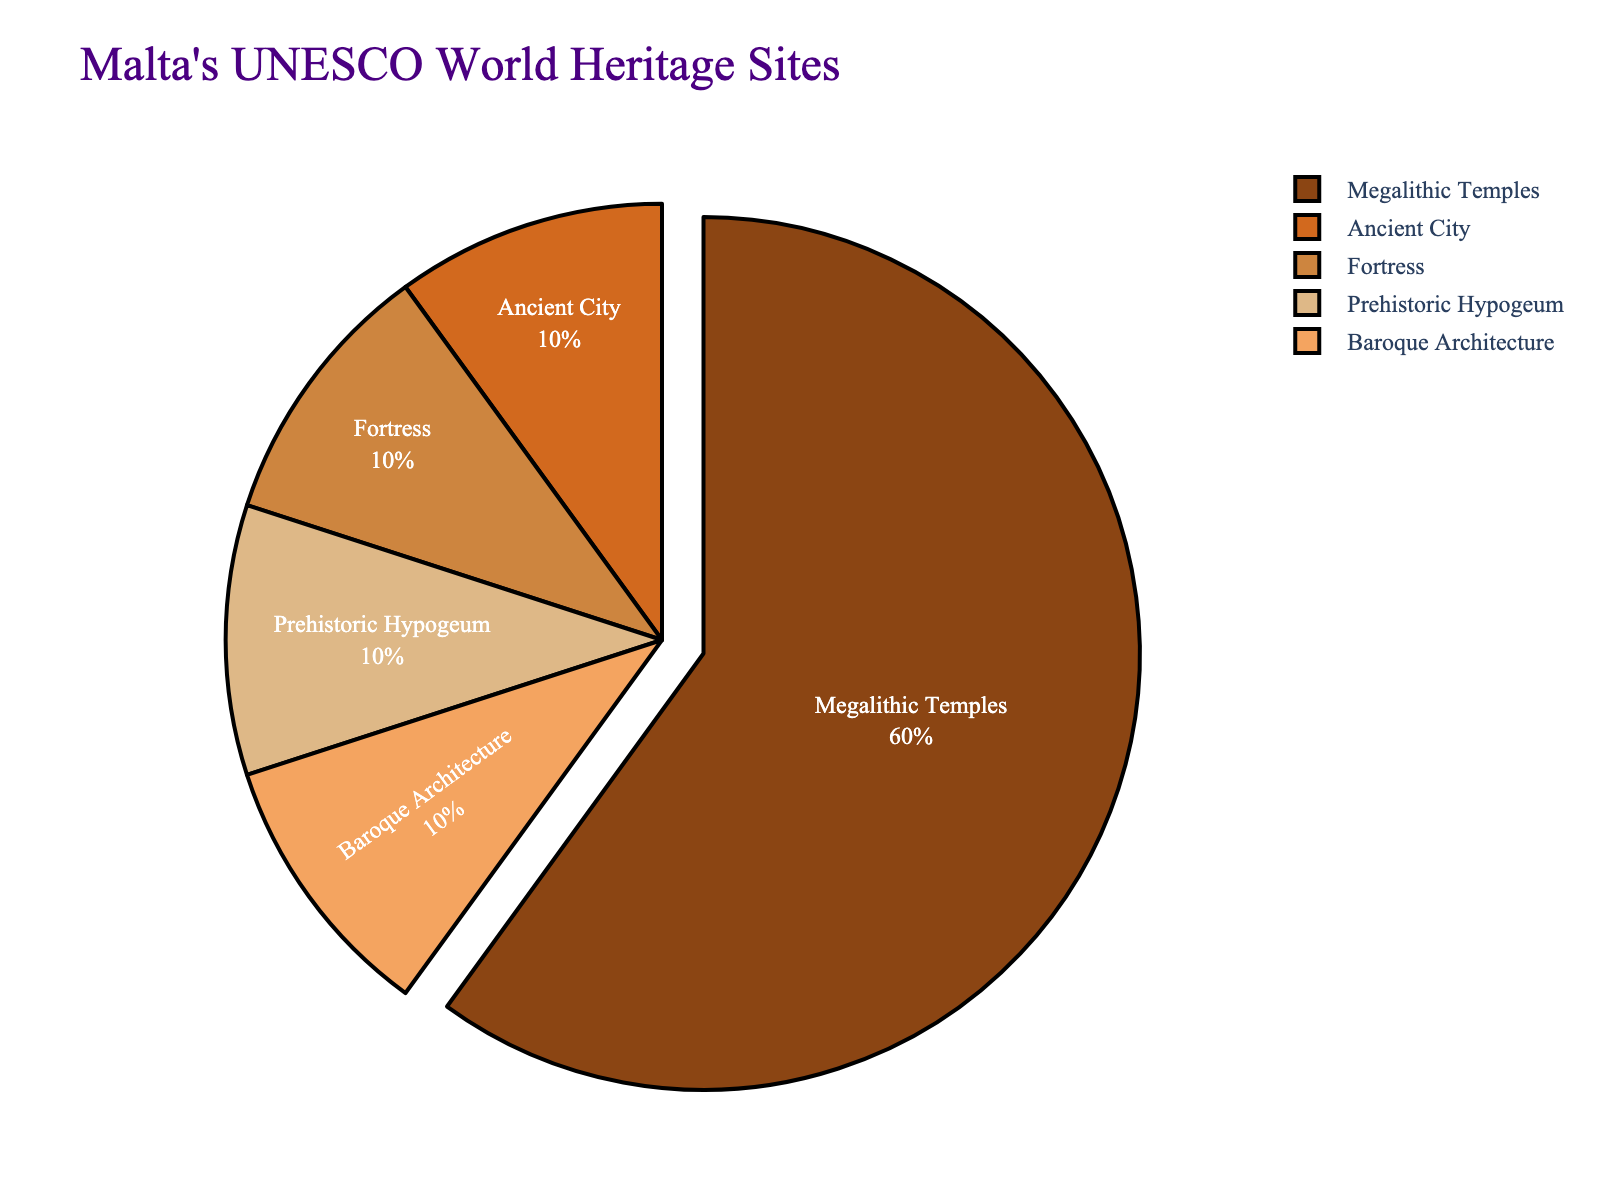What's the most common type of UNESCO World Heritage Site in Malta? From the pie chart, we observe that the slice representing the Megalithic Temples is the largest. This indicates that the Megalithic Temples have the highest count among the types listed.
Answer: Megalithic Temples How many more Megalithic Temples are there compared to Ancient Cities? The pie chart shows there are 6 Megalithic Temples and 1 Ancient City. The difference is calculated by 6 - 1.
Answer: 5 Which type of heritage site makes up exactly one-fifth of the total number of sites? The pie chart reveals that there are 5 types of heritage sites in Malta. With a total of 10 sites, one-fifth of the total number is 2. Therefore, the types with only 1 site each make up one-fifth of the total.
Answer: Ancient City, Fortress, Prehistoric Hypogeum, Baroque Architecture Is the number of Megalithic Temples at least three times greater than any other type of site? To determine this, divide the number of Megalithic Temples (6) by the number of any other type of site (1). 6 divided by 1 equals 6, which is certainly greater than 3.
Answer: Yes What percentage of Malta’s UNESCO World Heritage Sites are Fortress? The pie chart shows there is 1 Fortress out of 10 total sites. The percentage is calculated as (1/10) * 100, which is 10%.
Answer: 10% Which type of heritage site pulls out visually on the pie chart? Observing the pie chart, the pulled-out slice corresponds to the Megalithic Temples.
Answer: Megalithic Temples Compare and contrast the representation of Megalithic Temples and Baroque Architecture in the pie chart. Megalithic Temples have the largest portion with 6 sites, whereas Baroque Architecture has a much smaller portion with 1 site. The Megalithic Temples dominate the chart visually, while the Baroque Architecture section is considerably smaller.
Answer: Megalithic Temples are significantly more numerous How does the color representation aid in distinguishing between the different types of heritage sites? The pie chart uses distinct colors for each type of heritage site, making it easy to visually differentiate between them. This helps in identifying and comparing the portions without confusion.
Answer: It uses distinct colors 